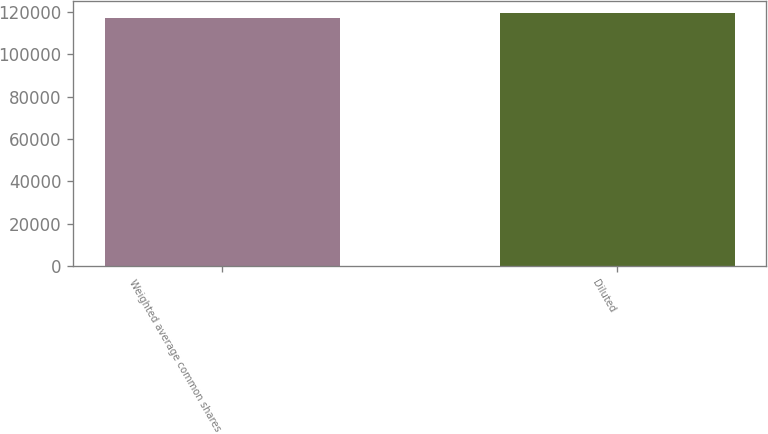Convert chart. <chart><loc_0><loc_0><loc_500><loc_500><bar_chart><fcel>Weighted average common shares<fcel>Diluted<nl><fcel>116904<fcel>119215<nl></chart> 